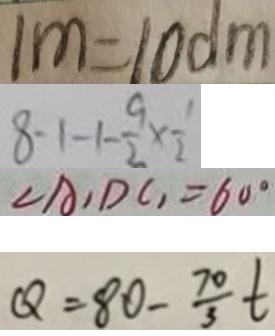Convert formula to latex. <formula><loc_0><loc_0><loc_500><loc_500>1 m = 1 0 d m 
 8 - 1 - 1 - \frac { 9 } { 2 } \times \frac { 1 } { 2 } 
 \angle A , D C , = 6 0 ^ { \circ } 
 Q = 8 0 - \frac { 7 0 } { 3 } t</formula> 